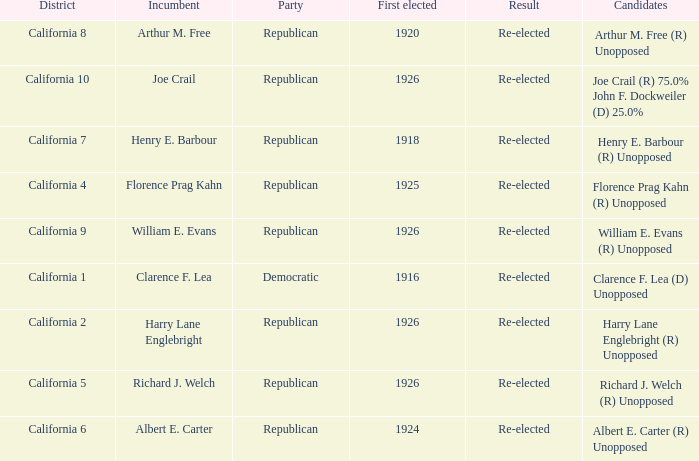What's the party with incumbent being william e. evans Republican. 